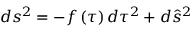Convert formula to latex. <formula><loc_0><loc_0><loc_500><loc_500>d s ^ { 2 } = - f \left ( \tau \right ) d \tau ^ { 2 } + d \hat { s } ^ { 2 }</formula> 